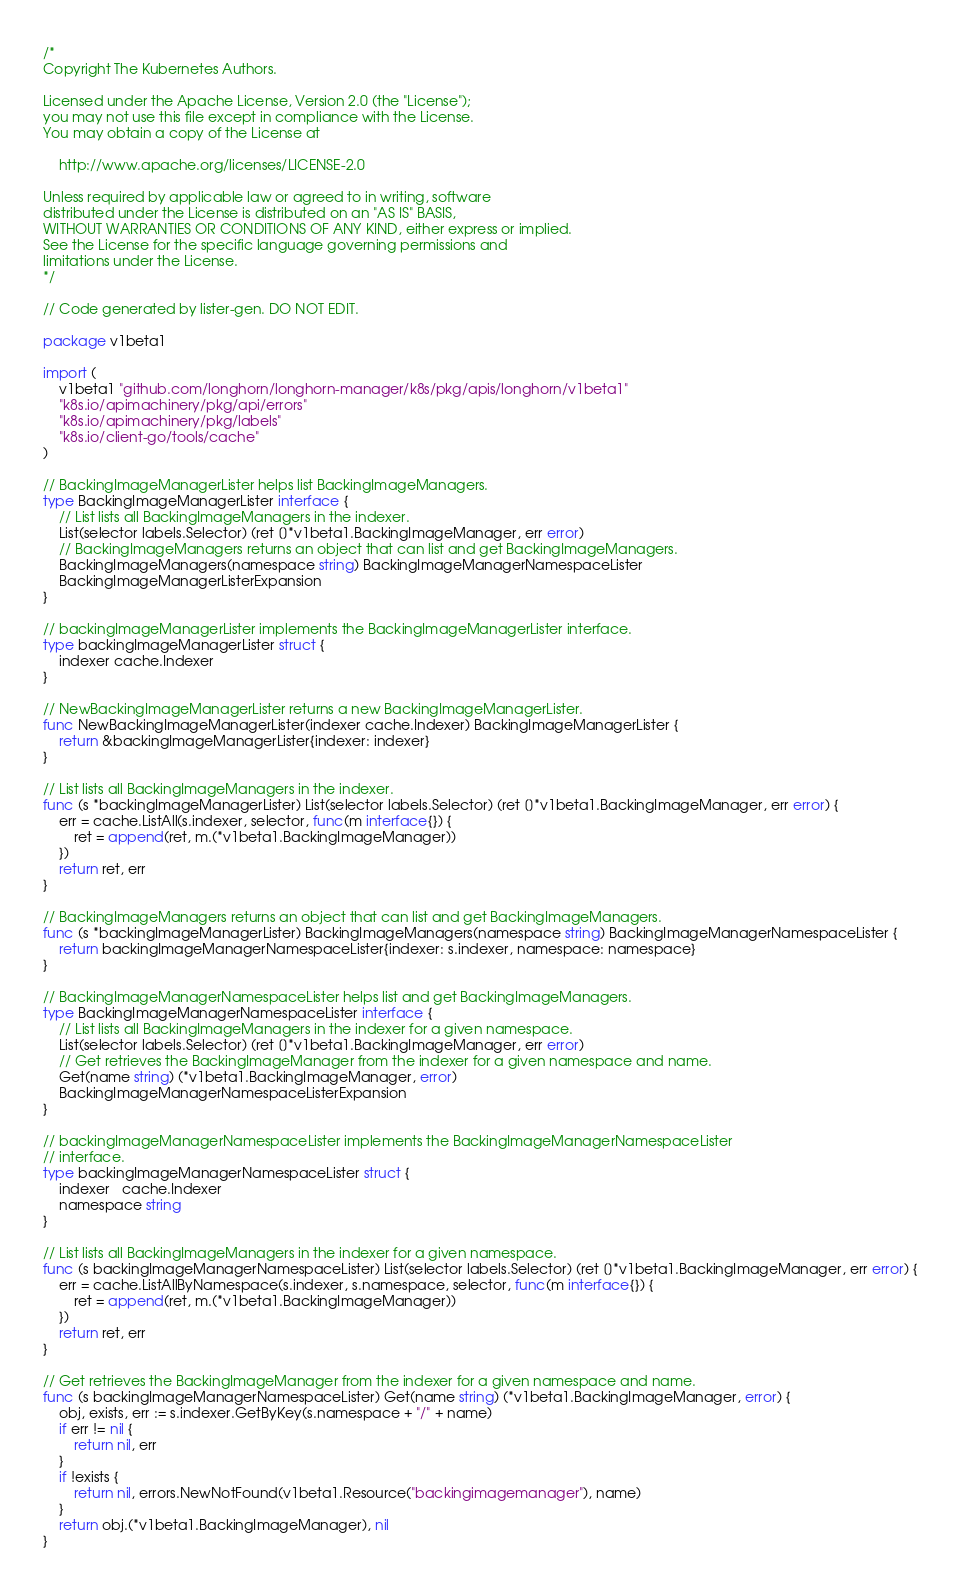<code> <loc_0><loc_0><loc_500><loc_500><_Go_>/*
Copyright The Kubernetes Authors.

Licensed under the Apache License, Version 2.0 (the "License");
you may not use this file except in compliance with the License.
You may obtain a copy of the License at

    http://www.apache.org/licenses/LICENSE-2.0

Unless required by applicable law or agreed to in writing, software
distributed under the License is distributed on an "AS IS" BASIS,
WITHOUT WARRANTIES OR CONDITIONS OF ANY KIND, either express or implied.
See the License for the specific language governing permissions and
limitations under the License.
*/

// Code generated by lister-gen. DO NOT EDIT.

package v1beta1

import (
	v1beta1 "github.com/longhorn/longhorn-manager/k8s/pkg/apis/longhorn/v1beta1"
	"k8s.io/apimachinery/pkg/api/errors"
	"k8s.io/apimachinery/pkg/labels"
	"k8s.io/client-go/tools/cache"
)

// BackingImageManagerLister helps list BackingImageManagers.
type BackingImageManagerLister interface {
	// List lists all BackingImageManagers in the indexer.
	List(selector labels.Selector) (ret []*v1beta1.BackingImageManager, err error)
	// BackingImageManagers returns an object that can list and get BackingImageManagers.
	BackingImageManagers(namespace string) BackingImageManagerNamespaceLister
	BackingImageManagerListerExpansion
}

// backingImageManagerLister implements the BackingImageManagerLister interface.
type backingImageManagerLister struct {
	indexer cache.Indexer
}

// NewBackingImageManagerLister returns a new BackingImageManagerLister.
func NewBackingImageManagerLister(indexer cache.Indexer) BackingImageManagerLister {
	return &backingImageManagerLister{indexer: indexer}
}

// List lists all BackingImageManagers in the indexer.
func (s *backingImageManagerLister) List(selector labels.Selector) (ret []*v1beta1.BackingImageManager, err error) {
	err = cache.ListAll(s.indexer, selector, func(m interface{}) {
		ret = append(ret, m.(*v1beta1.BackingImageManager))
	})
	return ret, err
}

// BackingImageManagers returns an object that can list and get BackingImageManagers.
func (s *backingImageManagerLister) BackingImageManagers(namespace string) BackingImageManagerNamespaceLister {
	return backingImageManagerNamespaceLister{indexer: s.indexer, namespace: namespace}
}

// BackingImageManagerNamespaceLister helps list and get BackingImageManagers.
type BackingImageManagerNamespaceLister interface {
	// List lists all BackingImageManagers in the indexer for a given namespace.
	List(selector labels.Selector) (ret []*v1beta1.BackingImageManager, err error)
	// Get retrieves the BackingImageManager from the indexer for a given namespace and name.
	Get(name string) (*v1beta1.BackingImageManager, error)
	BackingImageManagerNamespaceListerExpansion
}

// backingImageManagerNamespaceLister implements the BackingImageManagerNamespaceLister
// interface.
type backingImageManagerNamespaceLister struct {
	indexer   cache.Indexer
	namespace string
}

// List lists all BackingImageManagers in the indexer for a given namespace.
func (s backingImageManagerNamespaceLister) List(selector labels.Selector) (ret []*v1beta1.BackingImageManager, err error) {
	err = cache.ListAllByNamespace(s.indexer, s.namespace, selector, func(m interface{}) {
		ret = append(ret, m.(*v1beta1.BackingImageManager))
	})
	return ret, err
}

// Get retrieves the BackingImageManager from the indexer for a given namespace and name.
func (s backingImageManagerNamespaceLister) Get(name string) (*v1beta1.BackingImageManager, error) {
	obj, exists, err := s.indexer.GetByKey(s.namespace + "/" + name)
	if err != nil {
		return nil, err
	}
	if !exists {
		return nil, errors.NewNotFound(v1beta1.Resource("backingimagemanager"), name)
	}
	return obj.(*v1beta1.BackingImageManager), nil
}
</code> 